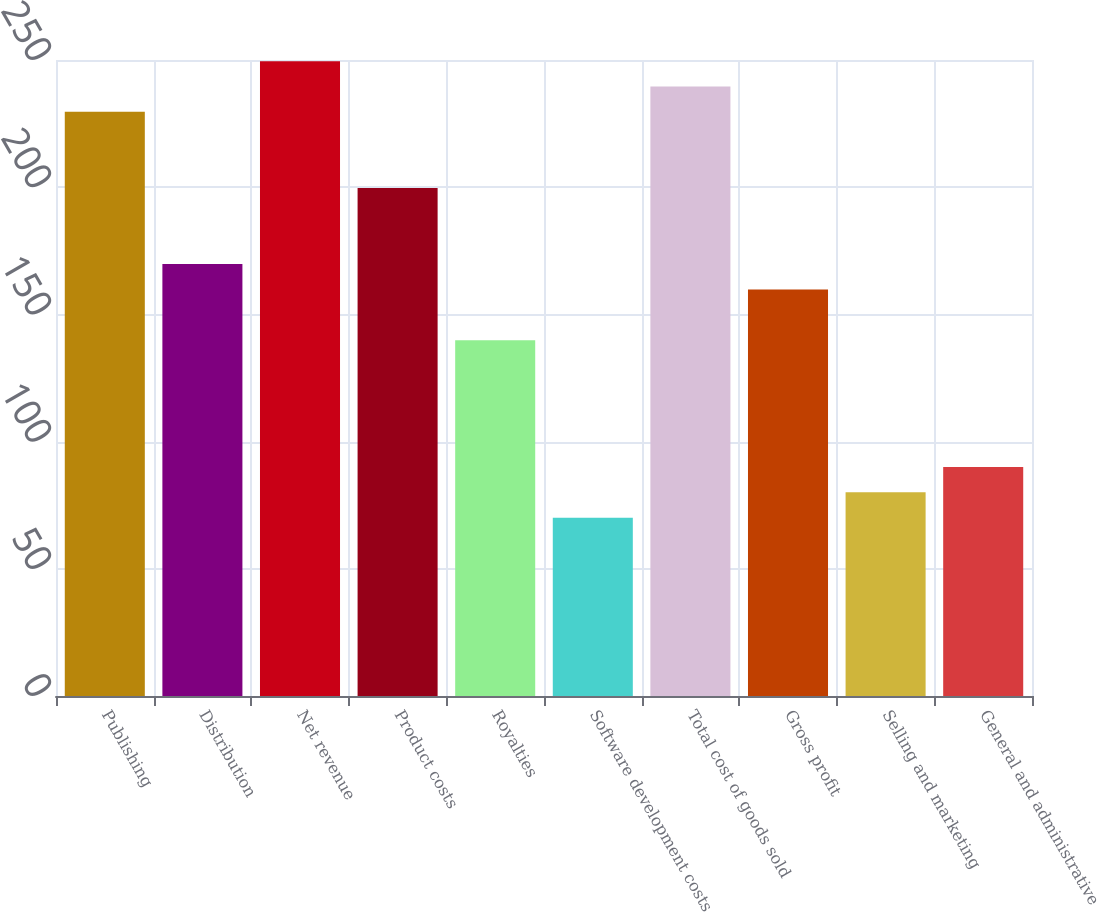Convert chart. <chart><loc_0><loc_0><loc_500><loc_500><bar_chart><fcel>Publishing<fcel>Distribution<fcel>Net revenue<fcel>Product costs<fcel>Royalties<fcel>Software development costs<fcel>Total cost of goods sold<fcel>Gross profit<fcel>Selling and marketing<fcel>General and administrative<nl><fcel>229.61<fcel>169.79<fcel>249.55<fcel>199.7<fcel>139.88<fcel>70.09<fcel>239.58<fcel>159.82<fcel>80.06<fcel>90.03<nl></chart> 